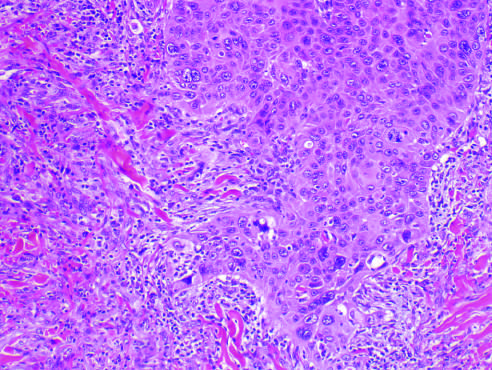did intramembranous characteristically dense deposits exhibit acantholysis?
Answer the question using a single word or phrase. No 